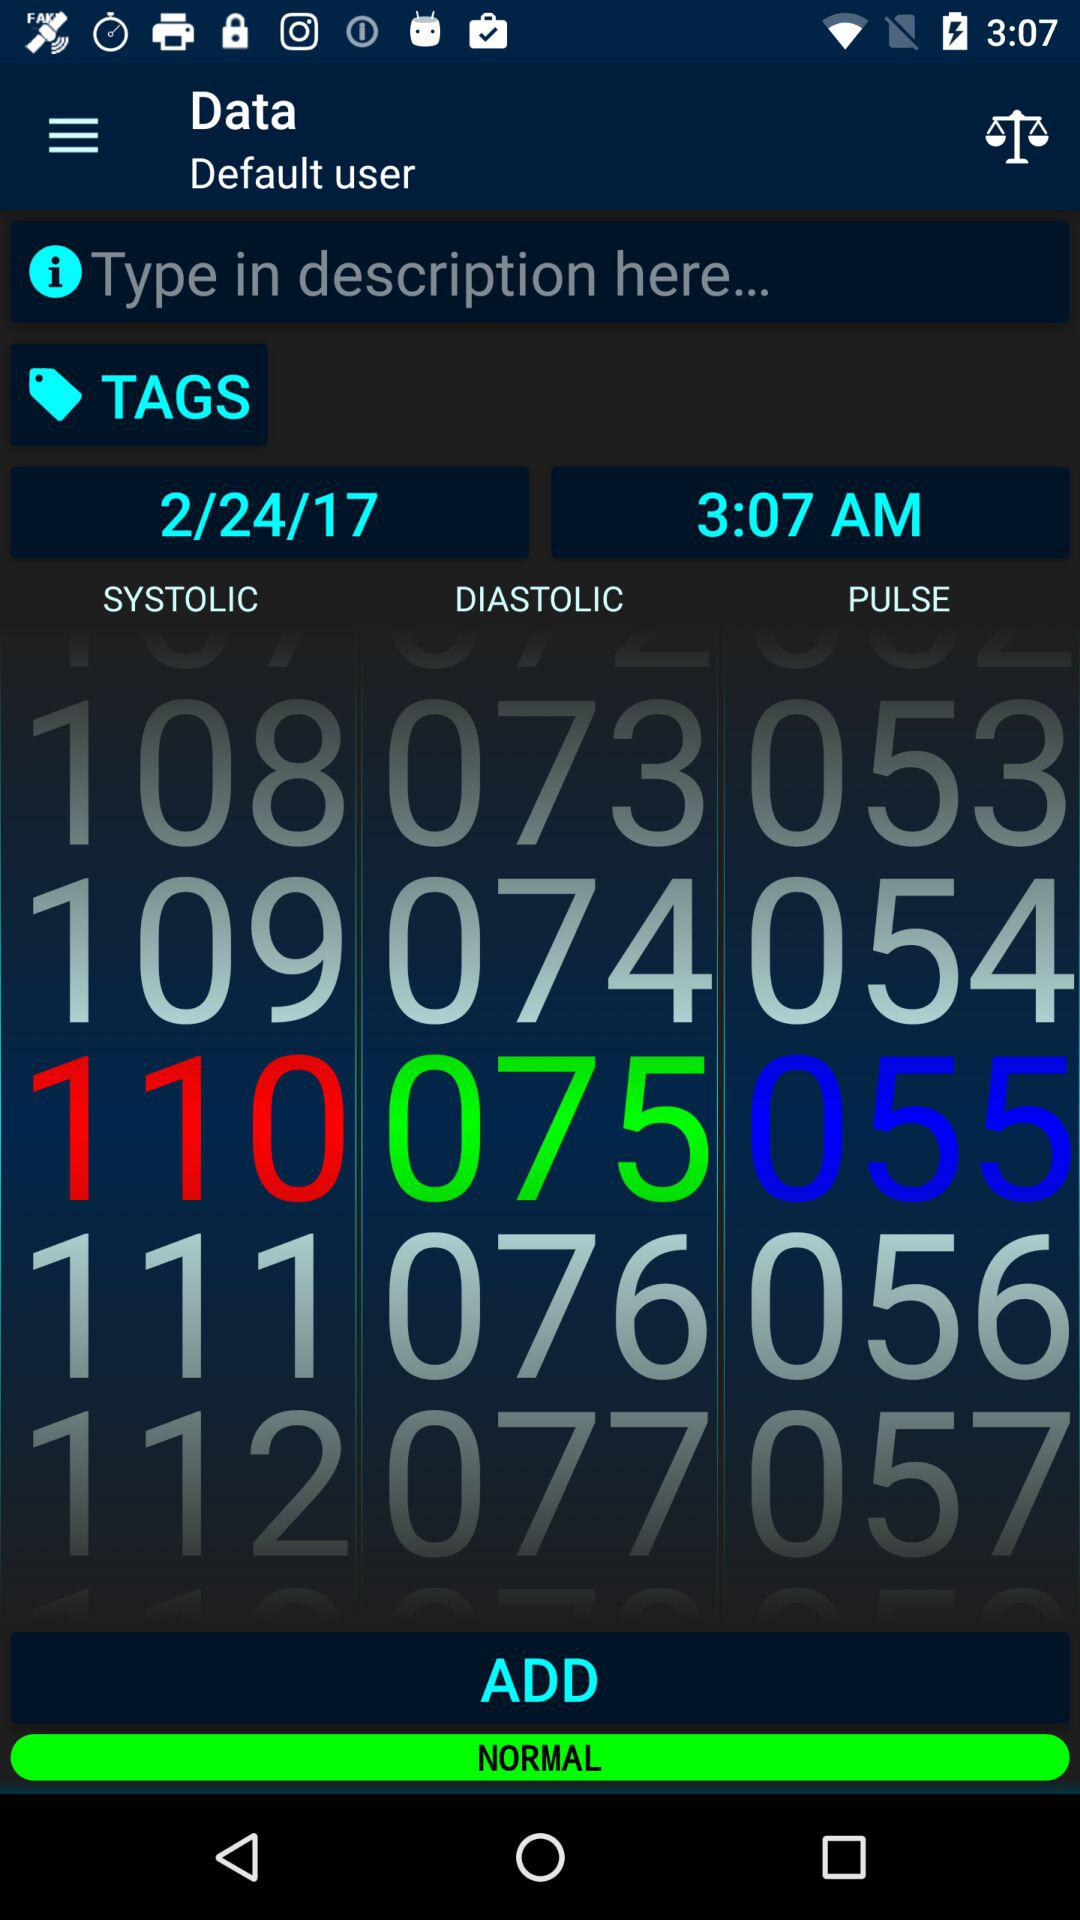What is the username?
When the provided information is insufficient, respond with <no answer>. <no answer> 